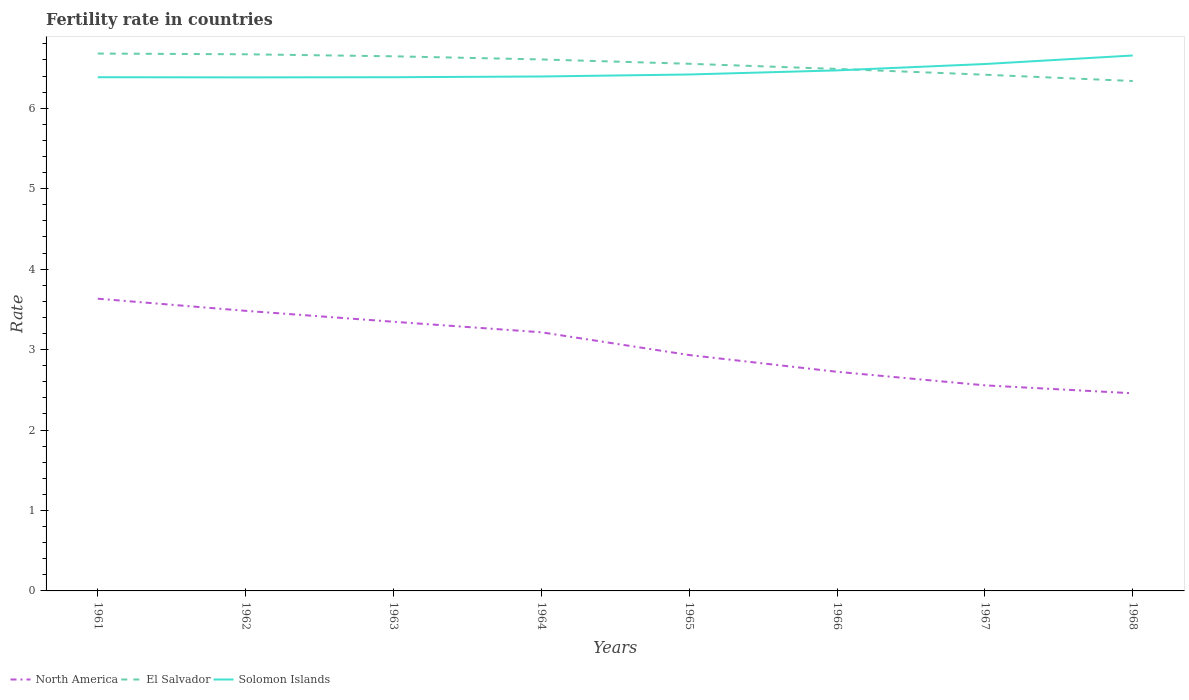Does the line corresponding to North America intersect with the line corresponding to El Salvador?
Your answer should be compact. No. Is the number of lines equal to the number of legend labels?
Ensure brevity in your answer.  Yes. Across all years, what is the maximum fertility rate in Solomon Islands?
Your answer should be very brief. 6.38. In which year was the fertility rate in North America maximum?
Offer a very short reply. 1968. What is the total fertility rate in North America in the graph?
Your response must be concise. 0.48. What is the difference between the highest and the second highest fertility rate in North America?
Your answer should be compact. 1.18. What is the difference between the highest and the lowest fertility rate in Solomon Islands?
Provide a short and direct response. 3. Is the fertility rate in El Salvador strictly greater than the fertility rate in North America over the years?
Your answer should be compact. No. How many lines are there?
Provide a succinct answer. 3. What is the difference between two consecutive major ticks on the Y-axis?
Provide a short and direct response. 1. Are the values on the major ticks of Y-axis written in scientific E-notation?
Your answer should be compact. No. Does the graph contain grids?
Offer a terse response. No. How many legend labels are there?
Give a very brief answer. 3. How are the legend labels stacked?
Ensure brevity in your answer.  Horizontal. What is the title of the graph?
Offer a terse response. Fertility rate in countries. Does "Canada" appear as one of the legend labels in the graph?
Ensure brevity in your answer.  No. What is the label or title of the X-axis?
Keep it short and to the point. Years. What is the label or title of the Y-axis?
Ensure brevity in your answer.  Rate. What is the Rate of North America in 1961?
Give a very brief answer. 3.63. What is the Rate of El Salvador in 1961?
Your answer should be very brief. 6.68. What is the Rate of Solomon Islands in 1961?
Offer a very short reply. 6.38. What is the Rate of North America in 1962?
Provide a succinct answer. 3.48. What is the Rate of El Salvador in 1962?
Make the answer very short. 6.67. What is the Rate in Solomon Islands in 1962?
Your response must be concise. 6.38. What is the Rate in North America in 1963?
Ensure brevity in your answer.  3.35. What is the Rate of El Salvador in 1963?
Offer a very short reply. 6.64. What is the Rate of Solomon Islands in 1963?
Provide a succinct answer. 6.38. What is the Rate in North America in 1964?
Provide a short and direct response. 3.21. What is the Rate of El Salvador in 1964?
Give a very brief answer. 6.61. What is the Rate in Solomon Islands in 1964?
Give a very brief answer. 6.39. What is the Rate of North America in 1965?
Offer a very short reply. 2.93. What is the Rate of El Salvador in 1965?
Offer a terse response. 6.55. What is the Rate of Solomon Islands in 1965?
Your response must be concise. 6.42. What is the Rate in North America in 1966?
Offer a terse response. 2.72. What is the Rate in El Salvador in 1966?
Your answer should be very brief. 6.49. What is the Rate in Solomon Islands in 1966?
Offer a very short reply. 6.47. What is the Rate of North America in 1967?
Make the answer very short. 2.56. What is the Rate of El Salvador in 1967?
Keep it short and to the point. 6.42. What is the Rate of Solomon Islands in 1967?
Provide a short and direct response. 6.55. What is the Rate of North America in 1968?
Provide a succinct answer. 2.46. What is the Rate in El Salvador in 1968?
Provide a succinct answer. 6.34. What is the Rate of Solomon Islands in 1968?
Keep it short and to the point. 6.66. Across all years, what is the maximum Rate of North America?
Your answer should be very brief. 3.63. Across all years, what is the maximum Rate of El Salvador?
Your answer should be compact. 6.68. Across all years, what is the maximum Rate in Solomon Islands?
Your answer should be compact. 6.66. Across all years, what is the minimum Rate of North America?
Provide a succinct answer. 2.46. Across all years, what is the minimum Rate of El Salvador?
Offer a terse response. 6.34. Across all years, what is the minimum Rate of Solomon Islands?
Offer a very short reply. 6.38. What is the total Rate of North America in the graph?
Offer a very short reply. 24.34. What is the total Rate of El Salvador in the graph?
Offer a terse response. 52.39. What is the total Rate of Solomon Islands in the graph?
Give a very brief answer. 51.64. What is the difference between the Rate of North America in 1961 and that in 1962?
Give a very brief answer. 0.15. What is the difference between the Rate of El Salvador in 1961 and that in 1962?
Offer a terse response. 0.01. What is the difference between the Rate of Solomon Islands in 1961 and that in 1962?
Ensure brevity in your answer.  0. What is the difference between the Rate in North America in 1961 and that in 1963?
Your response must be concise. 0.29. What is the difference between the Rate of El Salvador in 1961 and that in 1963?
Offer a very short reply. 0.03. What is the difference between the Rate in North America in 1961 and that in 1964?
Offer a terse response. 0.42. What is the difference between the Rate in El Salvador in 1961 and that in 1964?
Offer a terse response. 0.07. What is the difference between the Rate of Solomon Islands in 1961 and that in 1964?
Offer a very short reply. -0.01. What is the difference between the Rate in North America in 1961 and that in 1965?
Keep it short and to the point. 0.7. What is the difference between the Rate of El Salvador in 1961 and that in 1965?
Offer a very short reply. 0.13. What is the difference between the Rate in Solomon Islands in 1961 and that in 1965?
Your answer should be very brief. -0.03. What is the difference between the Rate of North America in 1961 and that in 1966?
Your answer should be compact. 0.91. What is the difference between the Rate in El Salvador in 1961 and that in 1966?
Keep it short and to the point. 0.19. What is the difference between the Rate of Solomon Islands in 1961 and that in 1966?
Your answer should be very brief. -0.09. What is the difference between the Rate in North America in 1961 and that in 1967?
Offer a very short reply. 1.08. What is the difference between the Rate of El Salvador in 1961 and that in 1967?
Provide a short and direct response. 0.26. What is the difference between the Rate of Solomon Islands in 1961 and that in 1967?
Make the answer very short. -0.16. What is the difference between the Rate in North America in 1961 and that in 1968?
Ensure brevity in your answer.  1.18. What is the difference between the Rate of El Salvador in 1961 and that in 1968?
Provide a succinct answer. 0.34. What is the difference between the Rate of Solomon Islands in 1961 and that in 1968?
Your answer should be compact. -0.27. What is the difference between the Rate in North America in 1962 and that in 1963?
Your response must be concise. 0.14. What is the difference between the Rate in El Salvador in 1962 and that in 1963?
Your response must be concise. 0.03. What is the difference between the Rate of Solomon Islands in 1962 and that in 1963?
Provide a short and direct response. -0. What is the difference between the Rate in North America in 1962 and that in 1964?
Make the answer very short. 0.27. What is the difference between the Rate of El Salvador in 1962 and that in 1964?
Your answer should be compact. 0.06. What is the difference between the Rate in Solomon Islands in 1962 and that in 1964?
Ensure brevity in your answer.  -0.01. What is the difference between the Rate of North America in 1962 and that in 1965?
Provide a short and direct response. 0.55. What is the difference between the Rate of El Salvador in 1962 and that in 1965?
Your answer should be compact. 0.12. What is the difference between the Rate of Solomon Islands in 1962 and that in 1965?
Give a very brief answer. -0.04. What is the difference between the Rate in North America in 1962 and that in 1966?
Offer a terse response. 0.76. What is the difference between the Rate in El Salvador in 1962 and that in 1966?
Provide a short and direct response. 0.18. What is the difference between the Rate of Solomon Islands in 1962 and that in 1966?
Offer a terse response. -0.09. What is the difference between the Rate in North America in 1962 and that in 1967?
Your response must be concise. 0.93. What is the difference between the Rate in El Salvador in 1962 and that in 1967?
Keep it short and to the point. 0.25. What is the difference between the Rate of Solomon Islands in 1962 and that in 1967?
Offer a terse response. -0.17. What is the difference between the Rate in North America in 1962 and that in 1968?
Provide a succinct answer. 1.02. What is the difference between the Rate in El Salvador in 1962 and that in 1968?
Ensure brevity in your answer.  0.33. What is the difference between the Rate in Solomon Islands in 1962 and that in 1968?
Keep it short and to the point. -0.27. What is the difference between the Rate in North America in 1963 and that in 1964?
Provide a succinct answer. 0.13. What is the difference between the Rate of El Salvador in 1963 and that in 1964?
Your answer should be compact. 0.04. What is the difference between the Rate of Solomon Islands in 1963 and that in 1964?
Your answer should be very brief. -0.01. What is the difference between the Rate in North America in 1963 and that in 1965?
Make the answer very short. 0.41. What is the difference between the Rate of El Salvador in 1963 and that in 1965?
Ensure brevity in your answer.  0.09. What is the difference between the Rate of Solomon Islands in 1963 and that in 1965?
Your response must be concise. -0.03. What is the difference between the Rate in North America in 1963 and that in 1966?
Give a very brief answer. 0.62. What is the difference between the Rate in El Salvador in 1963 and that in 1966?
Your answer should be very brief. 0.16. What is the difference between the Rate of Solomon Islands in 1963 and that in 1966?
Your response must be concise. -0.09. What is the difference between the Rate in North America in 1963 and that in 1967?
Keep it short and to the point. 0.79. What is the difference between the Rate in El Salvador in 1963 and that in 1967?
Give a very brief answer. 0.23. What is the difference between the Rate in Solomon Islands in 1963 and that in 1967?
Keep it short and to the point. -0.16. What is the difference between the Rate of North America in 1963 and that in 1968?
Offer a very short reply. 0.89. What is the difference between the Rate in El Salvador in 1963 and that in 1968?
Provide a succinct answer. 0.31. What is the difference between the Rate of Solomon Islands in 1963 and that in 1968?
Make the answer very short. -0.27. What is the difference between the Rate of North America in 1964 and that in 1965?
Offer a terse response. 0.28. What is the difference between the Rate in El Salvador in 1964 and that in 1965?
Ensure brevity in your answer.  0.05. What is the difference between the Rate in Solomon Islands in 1964 and that in 1965?
Give a very brief answer. -0.03. What is the difference between the Rate in North America in 1964 and that in 1966?
Ensure brevity in your answer.  0.49. What is the difference between the Rate in El Salvador in 1964 and that in 1966?
Your answer should be very brief. 0.12. What is the difference between the Rate in Solomon Islands in 1964 and that in 1966?
Make the answer very short. -0.08. What is the difference between the Rate in North America in 1964 and that in 1967?
Make the answer very short. 0.66. What is the difference between the Rate in El Salvador in 1964 and that in 1967?
Your answer should be compact. 0.19. What is the difference between the Rate of Solomon Islands in 1964 and that in 1967?
Make the answer very short. -0.15. What is the difference between the Rate of North America in 1964 and that in 1968?
Ensure brevity in your answer.  0.76. What is the difference between the Rate of El Salvador in 1964 and that in 1968?
Provide a short and direct response. 0.27. What is the difference between the Rate of Solomon Islands in 1964 and that in 1968?
Offer a very short reply. -0.26. What is the difference between the Rate of North America in 1965 and that in 1966?
Provide a succinct answer. 0.21. What is the difference between the Rate of El Salvador in 1965 and that in 1966?
Ensure brevity in your answer.  0.06. What is the difference between the Rate in Solomon Islands in 1965 and that in 1966?
Keep it short and to the point. -0.05. What is the difference between the Rate of North America in 1965 and that in 1967?
Your answer should be compact. 0.38. What is the difference between the Rate in El Salvador in 1965 and that in 1967?
Offer a very short reply. 0.14. What is the difference between the Rate in Solomon Islands in 1965 and that in 1967?
Your answer should be very brief. -0.13. What is the difference between the Rate of North America in 1965 and that in 1968?
Your answer should be very brief. 0.48. What is the difference between the Rate in El Salvador in 1965 and that in 1968?
Give a very brief answer. 0.21. What is the difference between the Rate of Solomon Islands in 1965 and that in 1968?
Give a very brief answer. -0.24. What is the difference between the Rate in North America in 1966 and that in 1967?
Provide a succinct answer. 0.17. What is the difference between the Rate in El Salvador in 1966 and that in 1967?
Provide a succinct answer. 0.07. What is the difference between the Rate of Solomon Islands in 1966 and that in 1967?
Your response must be concise. -0.08. What is the difference between the Rate in North America in 1966 and that in 1968?
Your answer should be very brief. 0.27. What is the difference between the Rate of El Salvador in 1966 and that in 1968?
Offer a terse response. 0.15. What is the difference between the Rate of Solomon Islands in 1966 and that in 1968?
Ensure brevity in your answer.  -0.18. What is the difference between the Rate of North America in 1967 and that in 1968?
Keep it short and to the point. 0.1. What is the difference between the Rate of El Salvador in 1967 and that in 1968?
Keep it short and to the point. 0.08. What is the difference between the Rate in Solomon Islands in 1967 and that in 1968?
Offer a very short reply. -0.11. What is the difference between the Rate of North America in 1961 and the Rate of El Salvador in 1962?
Keep it short and to the point. -3.04. What is the difference between the Rate in North America in 1961 and the Rate in Solomon Islands in 1962?
Ensure brevity in your answer.  -2.75. What is the difference between the Rate in El Salvador in 1961 and the Rate in Solomon Islands in 1962?
Offer a terse response. 0.3. What is the difference between the Rate of North America in 1961 and the Rate of El Salvador in 1963?
Make the answer very short. -3.01. What is the difference between the Rate in North America in 1961 and the Rate in Solomon Islands in 1963?
Make the answer very short. -2.75. What is the difference between the Rate of El Salvador in 1961 and the Rate of Solomon Islands in 1963?
Your answer should be very brief. 0.29. What is the difference between the Rate of North America in 1961 and the Rate of El Salvador in 1964?
Ensure brevity in your answer.  -2.97. What is the difference between the Rate of North America in 1961 and the Rate of Solomon Islands in 1964?
Provide a short and direct response. -2.76. What is the difference between the Rate in El Salvador in 1961 and the Rate in Solomon Islands in 1964?
Your response must be concise. 0.28. What is the difference between the Rate of North America in 1961 and the Rate of El Salvador in 1965?
Your answer should be compact. -2.92. What is the difference between the Rate in North America in 1961 and the Rate in Solomon Islands in 1965?
Provide a succinct answer. -2.79. What is the difference between the Rate of El Salvador in 1961 and the Rate of Solomon Islands in 1965?
Provide a short and direct response. 0.26. What is the difference between the Rate of North America in 1961 and the Rate of El Salvador in 1966?
Your answer should be compact. -2.86. What is the difference between the Rate of North America in 1961 and the Rate of Solomon Islands in 1966?
Your answer should be compact. -2.84. What is the difference between the Rate in El Salvador in 1961 and the Rate in Solomon Islands in 1966?
Provide a succinct answer. 0.21. What is the difference between the Rate of North America in 1961 and the Rate of El Salvador in 1967?
Give a very brief answer. -2.78. What is the difference between the Rate of North America in 1961 and the Rate of Solomon Islands in 1967?
Offer a terse response. -2.92. What is the difference between the Rate in El Salvador in 1961 and the Rate in Solomon Islands in 1967?
Provide a short and direct response. 0.13. What is the difference between the Rate of North America in 1961 and the Rate of El Salvador in 1968?
Your answer should be very brief. -2.71. What is the difference between the Rate in North America in 1961 and the Rate in Solomon Islands in 1968?
Your response must be concise. -3.02. What is the difference between the Rate in El Salvador in 1961 and the Rate in Solomon Islands in 1968?
Give a very brief answer. 0.02. What is the difference between the Rate of North America in 1962 and the Rate of El Salvador in 1963?
Ensure brevity in your answer.  -3.16. What is the difference between the Rate of North America in 1962 and the Rate of Solomon Islands in 1963?
Offer a very short reply. -2.9. What is the difference between the Rate in El Salvador in 1962 and the Rate in Solomon Islands in 1963?
Keep it short and to the point. 0.28. What is the difference between the Rate of North America in 1962 and the Rate of El Salvador in 1964?
Provide a short and direct response. -3.12. What is the difference between the Rate in North America in 1962 and the Rate in Solomon Islands in 1964?
Ensure brevity in your answer.  -2.91. What is the difference between the Rate in El Salvador in 1962 and the Rate in Solomon Islands in 1964?
Keep it short and to the point. 0.28. What is the difference between the Rate of North America in 1962 and the Rate of El Salvador in 1965?
Offer a very short reply. -3.07. What is the difference between the Rate in North America in 1962 and the Rate in Solomon Islands in 1965?
Ensure brevity in your answer.  -2.94. What is the difference between the Rate in El Salvador in 1962 and the Rate in Solomon Islands in 1965?
Your answer should be very brief. 0.25. What is the difference between the Rate of North America in 1962 and the Rate of El Salvador in 1966?
Provide a succinct answer. -3.01. What is the difference between the Rate in North America in 1962 and the Rate in Solomon Islands in 1966?
Provide a short and direct response. -2.99. What is the difference between the Rate of El Salvador in 1962 and the Rate of Solomon Islands in 1966?
Offer a very short reply. 0.2. What is the difference between the Rate in North America in 1962 and the Rate in El Salvador in 1967?
Your answer should be very brief. -2.93. What is the difference between the Rate in North America in 1962 and the Rate in Solomon Islands in 1967?
Offer a terse response. -3.07. What is the difference between the Rate of El Salvador in 1962 and the Rate of Solomon Islands in 1967?
Offer a terse response. 0.12. What is the difference between the Rate of North America in 1962 and the Rate of El Salvador in 1968?
Offer a terse response. -2.86. What is the difference between the Rate of North America in 1962 and the Rate of Solomon Islands in 1968?
Make the answer very short. -3.17. What is the difference between the Rate of El Salvador in 1962 and the Rate of Solomon Islands in 1968?
Provide a short and direct response. 0.01. What is the difference between the Rate in North America in 1963 and the Rate in El Salvador in 1964?
Give a very brief answer. -3.26. What is the difference between the Rate in North America in 1963 and the Rate in Solomon Islands in 1964?
Offer a very short reply. -3.05. What is the difference between the Rate in El Salvador in 1963 and the Rate in Solomon Islands in 1964?
Keep it short and to the point. 0.25. What is the difference between the Rate of North America in 1963 and the Rate of El Salvador in 1965?
Your answer should be very brief. -3.21. What is the difference between the Rate in North America in 1963 and the Rate in Solomon Islands in 1965?
Your answer should be compact. -3.07. What is the difference between the Rate in El Salvador in 1963 and the Rate in Solomon Islands in 1965?
Your response must be concise. 0.23. What is the difference between the Rate in North America in 1963 and the Rate in El Salvador in 1966?
Ensure brevity in your answer.  -3.14. What is the difference between the Rate of North America in 1963 and the Rate of Solomon Islands in 1966?
Give a very brief answer. -3.12. What is the difference between the Rate of El Salvador in 1963 and the Rate of Solomon Islands in 1966?
Offer a terse response. 0.17. What is the difference between the Rate in North America in 1963 and the Rate in El Salvador in 1967?
Your response must be concise. -3.07. What is the difference between the Rate in North America in 1963 and the Rate in Solomon Islands in 1967?
Provide a succinct answer. -3.2. What is the difference between the Rate in El Salvador in 1963 and the Rate in Solomon Islands in 1967?
Your answer should be very brief. 0.1. What is the difference between the Rate in North America in 1963 and the Rate in El Salvador in 1968?
Offer a very short reply. -2.99. What is the difference between the Rate of North America in 1963 and the Rate of Solomon Islands in 1968?
Make the answer very short. -3.31. What is the difference between the Rate in El Salvador in 1963 and the Rate in Solomon Islands in 1968?
Provide a succinct answer. -0.01. What is the difference between the Rate in North America in 1964 and the Rate in El Salvador in 1965?
Ensure brevity in your answer.  -3.34. What is the difference between the Rate of North America in 1964 and the Rate of Solomon Islands in 1965?
Your answer should be very brief. -3.2. What is the difference between the Rate of El Salvador in 1964 and the Rate of Solomon Islands in 1965?
Give a very brief answer. 0.19. What is the difference between the Rate of North America in 1964 and the Rate of El Salvador in 1966?
Offer a terse response. -3.27. What is the difference between the Rate in North America in 1964 and the Rate in Solomon Islands in 1966?
Your answer should be very brief. -3.26. What is the difference between the Rate in El Salvador in 1964 and the Rate in Solomon Islands in 1966?
Keep it short and to the point. 0.14. What is the difference between the Rate in North America in 1964 and the Rate in El Salvador in 1967?
Make the answer very short. -3.2. What is the difference between the Rate of North America in 1964 and the Rate of Solomon Islands in 1967?
Provide a short and direct response. -3.33. What is the difference between the Rate in El Salvador in 1964 and the Rate in Solomon Islands in 1967?
Your answer should be compact. 0.06. What is the difference between the Rate in North America in 1964 and the Rate in El Salvador in 1968?
Your answer should be compact. -3.12. What is the difference between the Rate in North America in 1964 and the Rate in Solomon Islands in 1968?
Offer a very short reply. -3.44. What is the difference between the Rate in El Salvador in 1964 and the Rate in Solomon Islands in 1968?
Give a very brief answer. -0.05. What is the difference between the Rate in North America in 1965 and the Rate in El Salvador in 1966?
Provide a short and direct response. -3.56. What is the difference between the Rate of North America in 1965 and the Rate of Solomon Islands in 1966?
Your answer should be very brief. -3.54. What is the difference between the Rate in El Salvador in 1965 and the Rate in Solomon Islands in 1966?
Your answer should be very brief. 0.08. What is the difference between the Rate in North America in 1965 and the Rate in El Salvador in 1967?
Provide a succinct answer. -3.48. What is the difference between the Rate in North America in 1965 and the Rate in Solomon Islands in 1967?
Provide a short and direct response. -3.62. What is the difference between the Rate in El Salvador in 1965 and the Rate in Solomon Islands in 1967?
Provide a short and direct response. 0. What is the difference between the Rate of North America in 1965 and the Rate of El Salvador in 1968?
Ensure brevity in your answer.  -3.41. What is the difference between the Rate in North America in 1965 and the Rate in Solomon Islands in 1968?
Provide a succinct answer. -3.72. What is the difference between the Rate in El Salvador in 1965 and the Rate in Solomon Islands in 1968?
Make the answer very short. -0.1. What is the difference between the Rate in North America in 1966 and the Rate in El Salvador in 1967?
Your response must be concise. -3.69. What is the difference between the Rate in North America in 1966 and the Rate in Solomon Islands in 1967?
Offer a very short reply. -3.83. What is the difference between the Rate in El Salvador in 1966 and the Rate in Solomon Islands in 1967?
Your answer should be compact. -0.06. What is the difference between the Rate of North America in 1966 and the Rate of El Salvador in 1968?
Your answer should be very brief. -3.61. What is the difference between the Rate of North America in 1966 and the Rate of Solomon Islands in 1968?
Your answer should be compact. -3.93. What is the difference between the Rate of El Salvador in 1966 and the Rate of Solomon Islands in 1968?
Give a very brief answer. -0.17. What is the difference between the Rate of North America in 1967 and the Rate of El Salvador in 1968?
Keep it short and to the point. -3.78. What is the difference between the Rate of North America in 1967 and the Rate of Solomon Islands in 1968?
Your answer should be compact. -4.1. What is the difference between the Rate of El Salvador in 1967 and the Rate of Solomon Islands in 1968?
Your answer should be compact. -0.24. What is the average Rate in North America per year?
Provide a short and direct response. 3.04. What is the average Rate of El Salvador per year?
Your response must be concise. 6.55. What is the average Rate of Solomon Islands per year?
Ensure brevity in your answer.  6.46. In the year 1961, what is the difference between the Rate of North America and Rate of El Salvador?
Provide a short and direct response. -3.05. In the year 1961, what is the difference between the Rate of North America and Rate of Solomon Islands?
Provide a short and direct response. -2.75. In the year 1961, what is the difference between the Rate of El Salvador and Rate of Solomon Islands?
Give a very brief answer. 0.29. In the year 1962, what is the difference between the Rate in North America and Rate in El Salvador?
Offer a terse response. -3.19. In the year 1962, what is the difference between the Rate of North America and Rate of Solomon Islands?
Offer a terse response. -2.9. In the year 1962, what is the difference between the Rate of El Salvador and Rate of Solomon Islands?
Your answer should be compact. 0.29. In the year 1963, what is the difference between the Rate of North America and Rate of El Salvador?
Provide a succinct answer. -3.3. In the year 1963, what is the difference between the Rate of North America and Rate of Solomon Islands?
Your answer should be compact. -3.04. In the year 1963, what is the difference between the Rate of El Salvador and Rate of Solomon Islands?
Provide a succinct answer. 0.26. In the year 1964, what is the difference between the Rate of North America and Rate of El Salvador?
Ensure brevity in your answer.  -3.39. In the year 1964, what is the difference between the Rate in North America and Rate in Solomon Islands?
Provide a short and direct response. -3.18. In the year 1964, what is the difference between the Rate of El Salvador and Rate of Solomon Islands?
Your response must be concise. 0.21. In the year 1965, what is the difference between the Rate in North America and Rate in El Salvador?
Your answer should be compact. -3.62. In the year 1965, what is the difference between the Rate in North America and Rate in Solomon Islands?
Keep it short and to the point. -3.49. In the year 1965, what is the difference between the Rate of El Salvador and Rate of Solomon Islands?
Your response must be concise. 0.13. In the year 1966, what is the difference between the Rate in North America and Rate in El Salvador?
Ensure brevity in your answer.  -3.76. In the year 1966, what is the difference between the Rate of North America and Rate of Solomon Islands?
Offer a terse response. -3.75. In the year 1966, what is the difference between the Rate of El Salvador and Rate of Solomon Islands?
Your answer should be compact. 0.02. In the year 1967, what is the difference between the Rate in North America and Rate in El Salvador?
Provide a succinct answer. -3.86. In the year 1967, what is the difference between the Rate in North America and Rate in Solomon Islands?
Your answer should be very brief. -3.99. In the year 1967, what is the difference between the Rate of El Salvador and Rate of Solomon Islands?
Ensure brevity in your answer.  -0.13. In the year 1968, what is the difference between the Rate of North America and Rate of El Salvador?
Your answer should be compact. -3.88. In the year 1968, what is the difference between the Rate in North America and Rate in Solomon Islands?
Your answer should be very brief. -4.2. In the year 1968, what is the difference between the Rate of El Salvador and Rate of Solomon Islands?
Ensure brevity in your answer.  -0.32. What is the ratio of the Rate in North America in 1961 to that in 1962?
Keep it short and to the point. 1.04. What is the ratio of the Rate in Solomon Islands in 1961 to that in 1962?
Ensure brevity in your answer.  1. What is the ratio of the Rate in North America in 1961 to that in 1963?
Provide a short and direct response. 1.09. What is the ratio of the Rate in El Salvador in 1961 to that in 1963?
Offer a very short reply. 1.01. What is the ratio of the Rate of North America in 1961 to that in 1964?
Make the answer very short. 1.13. What is the ratio of the Rate of El Salvador in 1961 to that in 1964?
Offer a terse response. 1.01. What is the ratio of the Rate in North America in 1961 to that in 1965?
Provide a short and direct response. 1.24. What is the ratio of the Rate in El Salvador in 1961 to that in 1965?
Offer a terse response. 1.02. What is the ratio of the Rate of North America in 1961 to that in 1966?
Your answer should be compact. 1.33. What is the ratio of the Rate in El Salvador in 1961 to that in 1966?
Give a very brief answer. 1.03. What is the ratio of the Rate in Solomon Islands in 1961 to that in 1966?
Make the answer very short. 0.99. What is the ratio of the Rate of North America in 1961 to that in 1967?
Offer a terse response. 1.42. What is the ratio of the Rate in El Salvador in 1961 to that in 1967?
Your answer should be compact. 1.04. What is the ratio of the Rate of North America in 1961 to that in 1968?
Provide a succinct answer. 1.48. What is the ratio of the Rate in El Salvador in 1961 to that in 1968?
Offer a terse response. 1.05. What is the ratio of the Rate in Solomon Islands in 1961 to that in 1968?
Offer a terse response. 0.96. What is the ratio of the Rate in North America in 1962 to that in 1963?
Your answer should be very brief. 1.04. What is the ratio of the Rate of El Salvador in 1962 to that in 1963?
Give a very brief answer. 1. What is the ratio of the Rate of North America in 1962 to that in 1964?
Your answer should be very brief. 1.08. What is the ratio of the Rate of El Salvador in 1962 to that in 1964?
Your answer should be very brief. 1.01. What is the ratio of the Rate of North America in 1962 to that in 1965?
Offer a terse response. 1.19. What is the ratio of the Rate of North America in 1962 to that in 1966?
Your answer should be compact. 1.28. What is the ratio of the Rate in El Salvador in 1962 to that in 1966?
Provide a short and direct response. 1.03. What is the ratio of the Rate in Solomon Islands in 1962 to that in 1966?
Provide a succinct answer. 0.99. What is the ratio of the Rate of North America in 1962 to that in 1967?
Your answer should be compact. 1.36. What is the ratio of the Rate of El Salvador in 1962 to that in 1967?
Offer a very short reply. 1.04. What is the ratio of the Rate of Solomon Islands in 1962 to that in 1967?
Your answer should be very brief. 0.97. What is the ratio of the Rate in North America in 1962 to that in 1968?
Make the answer very short. 1.42. What is the ratio of the Rate of El Salvador in 1962 to that in 1968?
Offer a very short reply. 1.05. What is the ratio of the Rate of Solomon Islands in 1962 to that in 1968?
Give a very brief answer. 0.96. What is the ratio of the Rate of North America in 1963 to that in 1964?
Offer a very short reply. 1.04. What is the ratio of the Rate in El Salvador in 1963 to that in 1964?
Your response must be concise. 1.01. What is the ratio of the Rate in North America in 1963 to that in 1965?
Offer a very short reply. 1.14. What is the ratio of the Rate of El Salvador in 1963 to that in 1965?
Your response must be concise. 1.01. What is the ratio of the Rate of Solomon Islands in 1963 to that in 1965?
Your answer should be compact. 0.99. What is the ratio of the Rate in North America in 1963 to that in 1966?
Ensure brevity in your answer.  1.23. What is the ratio of the Rate in El Salvador in 1963 to that in 1966?
Provide a short and direct response. 1.02. What is the ratio of the Rate in Solomon Islands in 1963 to that in 1966?
Make the answer very short. 0.99. What is the ratio of the Rate of North America in 1963 to that in 1967?
Your answer should be compact. 1.31. What is the ratio of the Rate in El Salvador in 1963 to that in 1967?
Make the answer very short. 1.04. What is the ratio of the Rate of Solomon Islands in 1963 to that in 1967?
Ensure brevity in your answer.  0.97. What is the ratio of the Rate of North America in 1963 to that in 1968?
Your answer should be very brief. 1.36. What is the ratio of the Rate in El Salvador in 1963 to that in 1968?
Make the answer very short. 1.05. What is the ratio of the Rate of Solomon Islands in 1963 to that in 1968?
Provide a short and direct response. 0.96. What is the ratio of the Rate of North America in 1964 to that in 1965?
Offer a very short reply. 1.1. What is the ratio of the Rate of El Salvador in 1964 to that in 1965?
Keep it short and to the point. 1.01. What is the ratio of the Rate of North America in 1964 to that in 1966?
Keep it short and to the point. 1.18. What is the ratio of the Rate of El Salvador in 1964 to that in 1966?
Offer a very short reply. 1.02. What is the ratio of the Rate in Solomon Islands in 1964 to that in 1966?
Provide a short and direct response. 0.99. What is the ratio of the Rate of North America in 1964 to that in 1967?
Make the answer very short. 1.26. What is the ratio of the Rate of El Salvador in 1964 to that in 1967?
Your response must be concise. 1.03. What is the ratio of the Rate in Solomon Islands in 1964 to that in 1967?
Your response must be concise. 0.98. What is the ratio of the Rate of North America in 1964 to that in 1968?
Ensure brevity in your answer.  1.31. What is the ratio of the Rate in El Salvador in 1964 to that in 1968?
Your response must be concise. 1.04. What is the ratio of the Rate of Solomon Islands in 1964 to that in 1968?
Offer a very short reply. 0.96. What is the ratio of the Rate in North America in 1965 to that in 1966?
Make the answer very short. 1.08. What is the ratio of the Rate of El Salvador in 1965 to that in 1966?
Your response must be concise. 1.01. What is the ratio of the Rate in North America in 1965 to that in 1967?
Give a very brief answer. 1.15. What is the ratio of the Rate in El Salvador in 1965 to that in 1967?
Make the answer very short. 1.02. What is the ratio of the Rate of Solomon Islands in 1965 to that in 1967?
Make the answer very short. 0.98. What is the ratio of the Rate in North America in 1965 to that in 1968?
Ensure brevity in your answer.  1.19. What is the ratio of the Rate in El Salvador in 1965 to that in 1968?
Your answer should be compact. 1.03. What is the ratio of the Rate of Solomon Islands in 1965 to that in 1968?
Your answer should be compact. 0.96. What is the ratio of the Rate in North America in 1966 to that in 1967?
Your response must be concise. 1.07. What is the ratio of the Rate of El Salvador in 1966 to that in 1967?
Offer a very short reply. 1.01. What is the ratio of the Rate of Solomon Islands in 1966 to that in 1967?
Your response must be concise. 0.99. What is the ratio of the Rate in North America in 1966 to that in 1968?
Ensure brevity in your answer.  1.11. What is the ratio of the Rate of El Salvador in 1966 to that in 1968?
Keep it short and to the point. 1.02. What is the ratio of the Rate in Solomon Islands in 1966 to that in 1968?
Provide a succinct answer. 0.97. What is the ratio of the Rate of North America in 1967 to that in 1968?
Ensure brevity in your answer.  1.04. What is the ratio of the Rate in El Salvador in 1967 to that in 1968?
Provide a succinct answer. 1.01. What is the ratio of the Rate in Solomon Islands in 1967 to that in 1968?
Your answer should be compact. 0.98. What is the difference between the highest and the second highest Rate in North America?
Your response must be concise. 0.15. What is the difference between the highest and the second highest Rate of El Salvador?
Provide a short and direct response. 0.01. What is the difference between the highest and the second highest Rate in Solomon Islands?
Offer a terse response. 0.11. What is the difference between the highest and the lowest Rate of North America?
Your response must be concise. 1.18. What is the difference between the highest and the lowest Rate of El Salvador?
Offer a very short reply. 0.34. What is the difference between the highest and the lowest Rate in Solomon Islands?
Give a very brief answer. 0.27. 